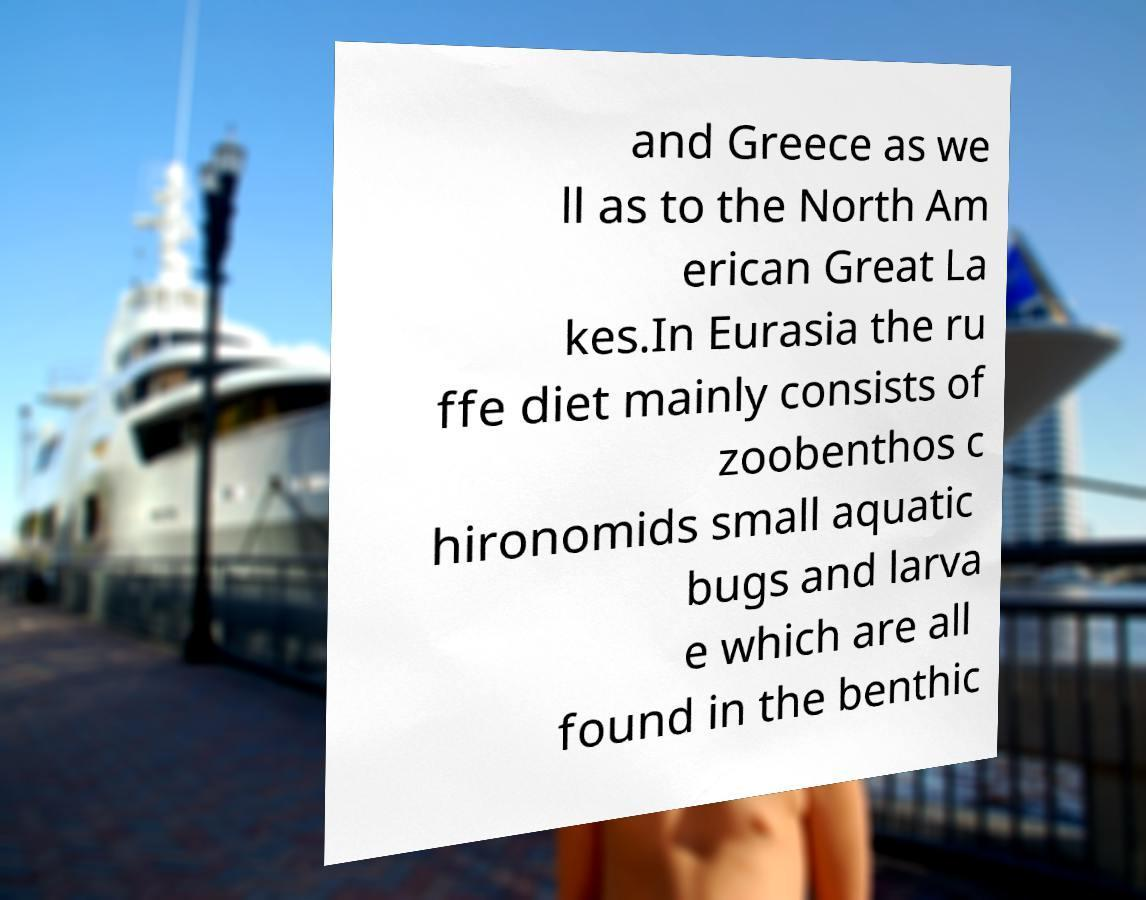I need the written content from this picture converted into text. Can you do that? and Greece as we ll as to the North Am erican Great La kes.In Eurasia the ru ffe diet mainly consists of zoobenthos c hironomids small aquatic bugs and larva e which are all found in the benthic 